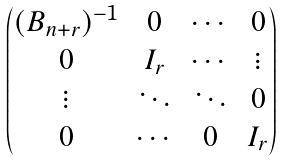<formula> <loc_0><loc_0><loc_500><loc_500>\begin{pmatrix} ( B _ { n + r } ) ^ { - 1 } & 0 & \cdots & 0 \\ 0 & I _ { r } & \cdots & \vdots \\ \vdots & \ddots & \ddots & 0 \\ 0 & \cdots & 0 & I _ { r } \end{pmatrix}</formula> 